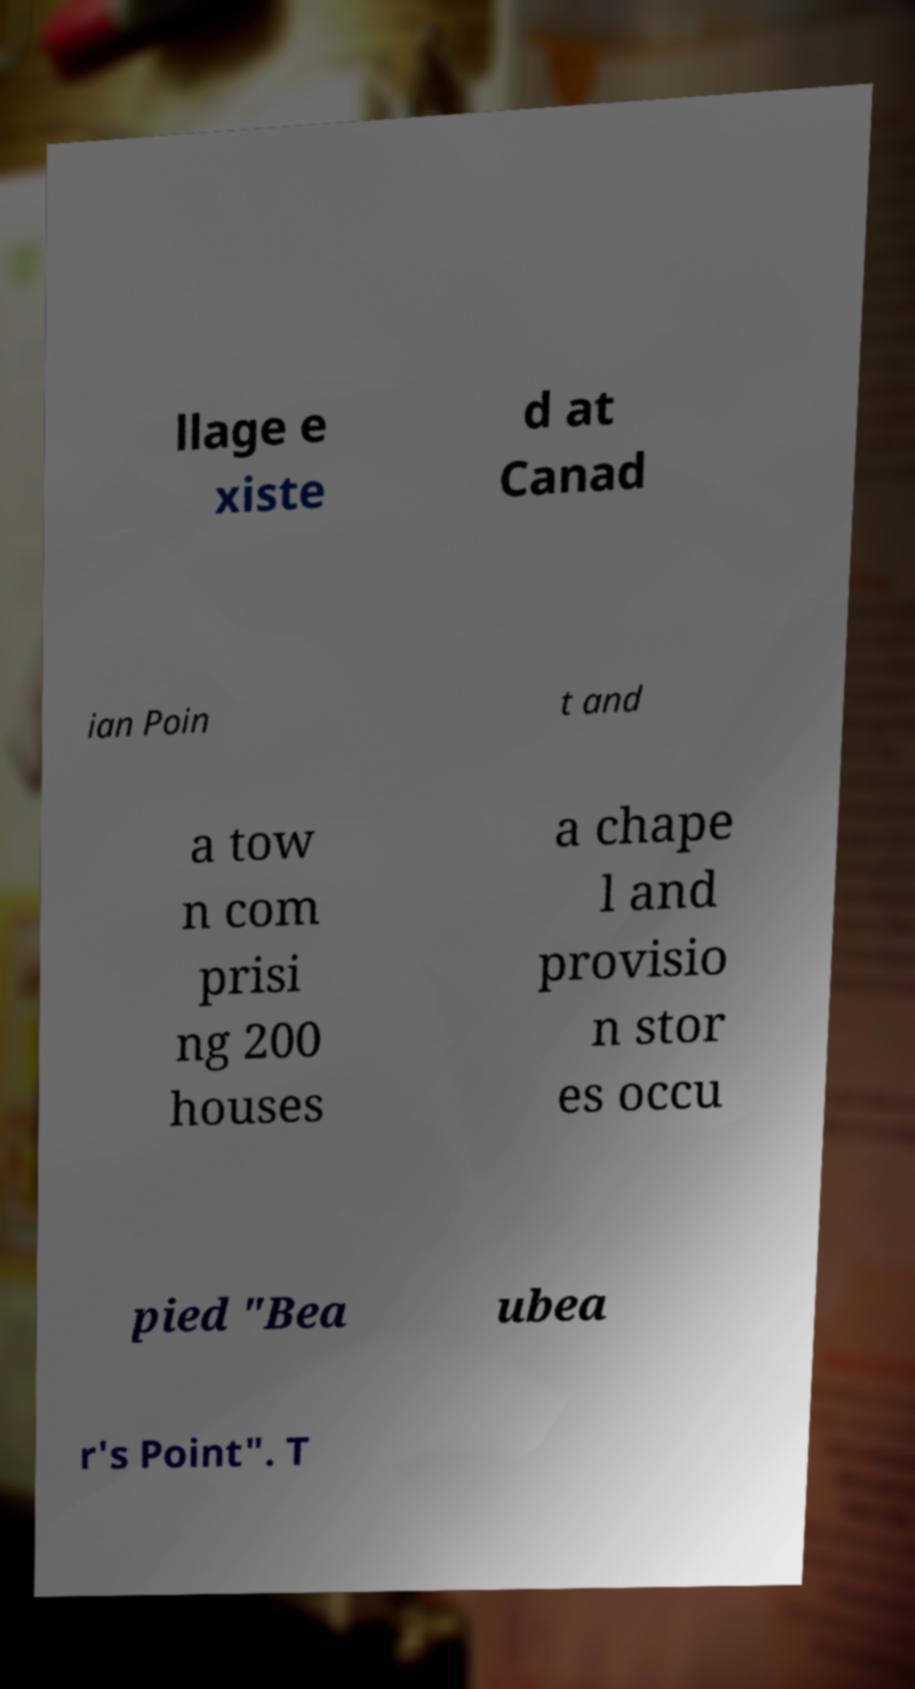Can you accurately transcribe the text from the provided image for me? llage e xiste d at Canad ian Poin t and a tow n com prisi ng 200 houses a chape l and provisio n stor es occu pied "Bea ubea r's Point". T 